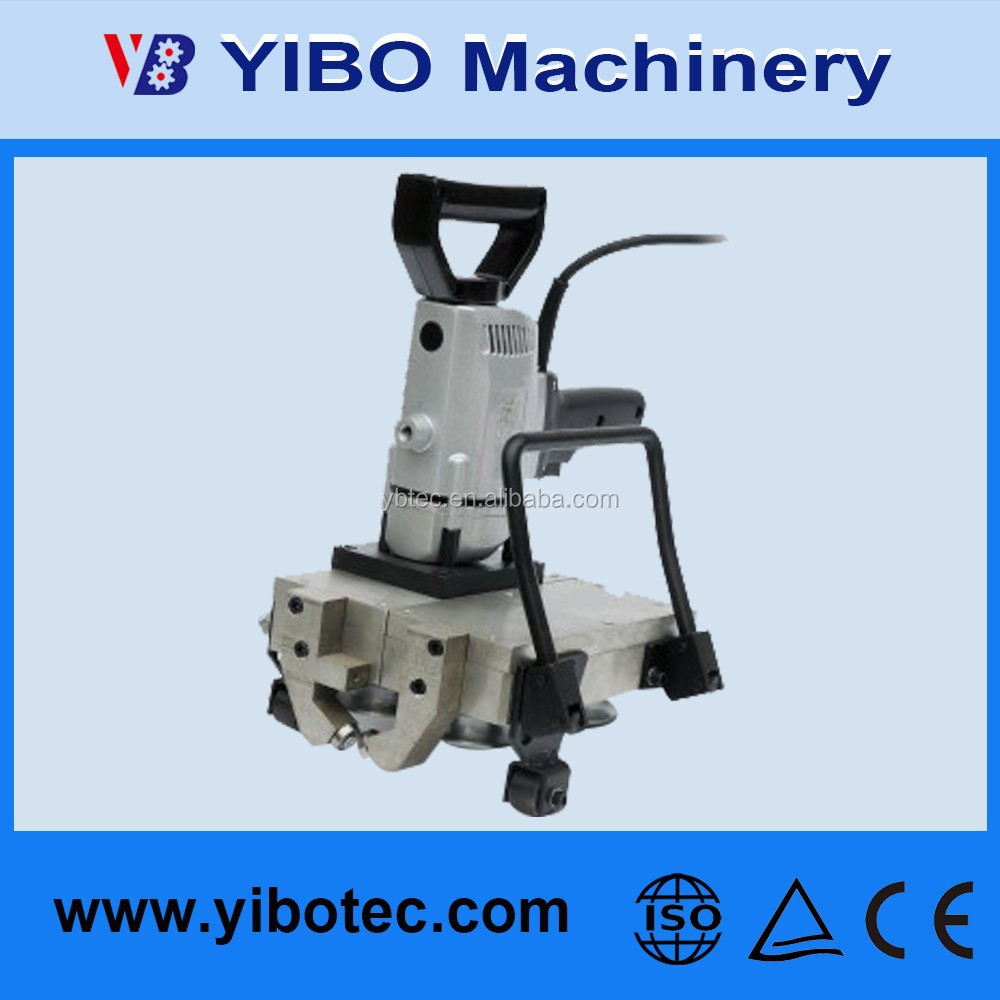Considering the symbols visible on the machine, what can be inferred about the standards and regulations this piece of equipment complies with, and how does this influence the regions or markets where it could be sold and used? The symbols visible on the machine provide valuable information regarding the standards and regulations it complies with. The CE marking is a certification that signifies the machine meets the stringent safety, health, and environmental protection requirements set by the European Union, which makes it eligible for sale and use within the European Economic Area (EEA). The ISO symbol indicates that the equipment adheres to the standards set by the International Organization for Standardization, reflecting globally recognized quality and safety practices. Additionally, the presence of warning symbols suggests that there are specific instructions and safety guidelines that must be followed during operation. These certifications suggest that the machine is designed for broad international distribution, particularly targeting regions that mandate these standards for industrial equipment, thereby ensuring its marketability and compliance on a global scale. 